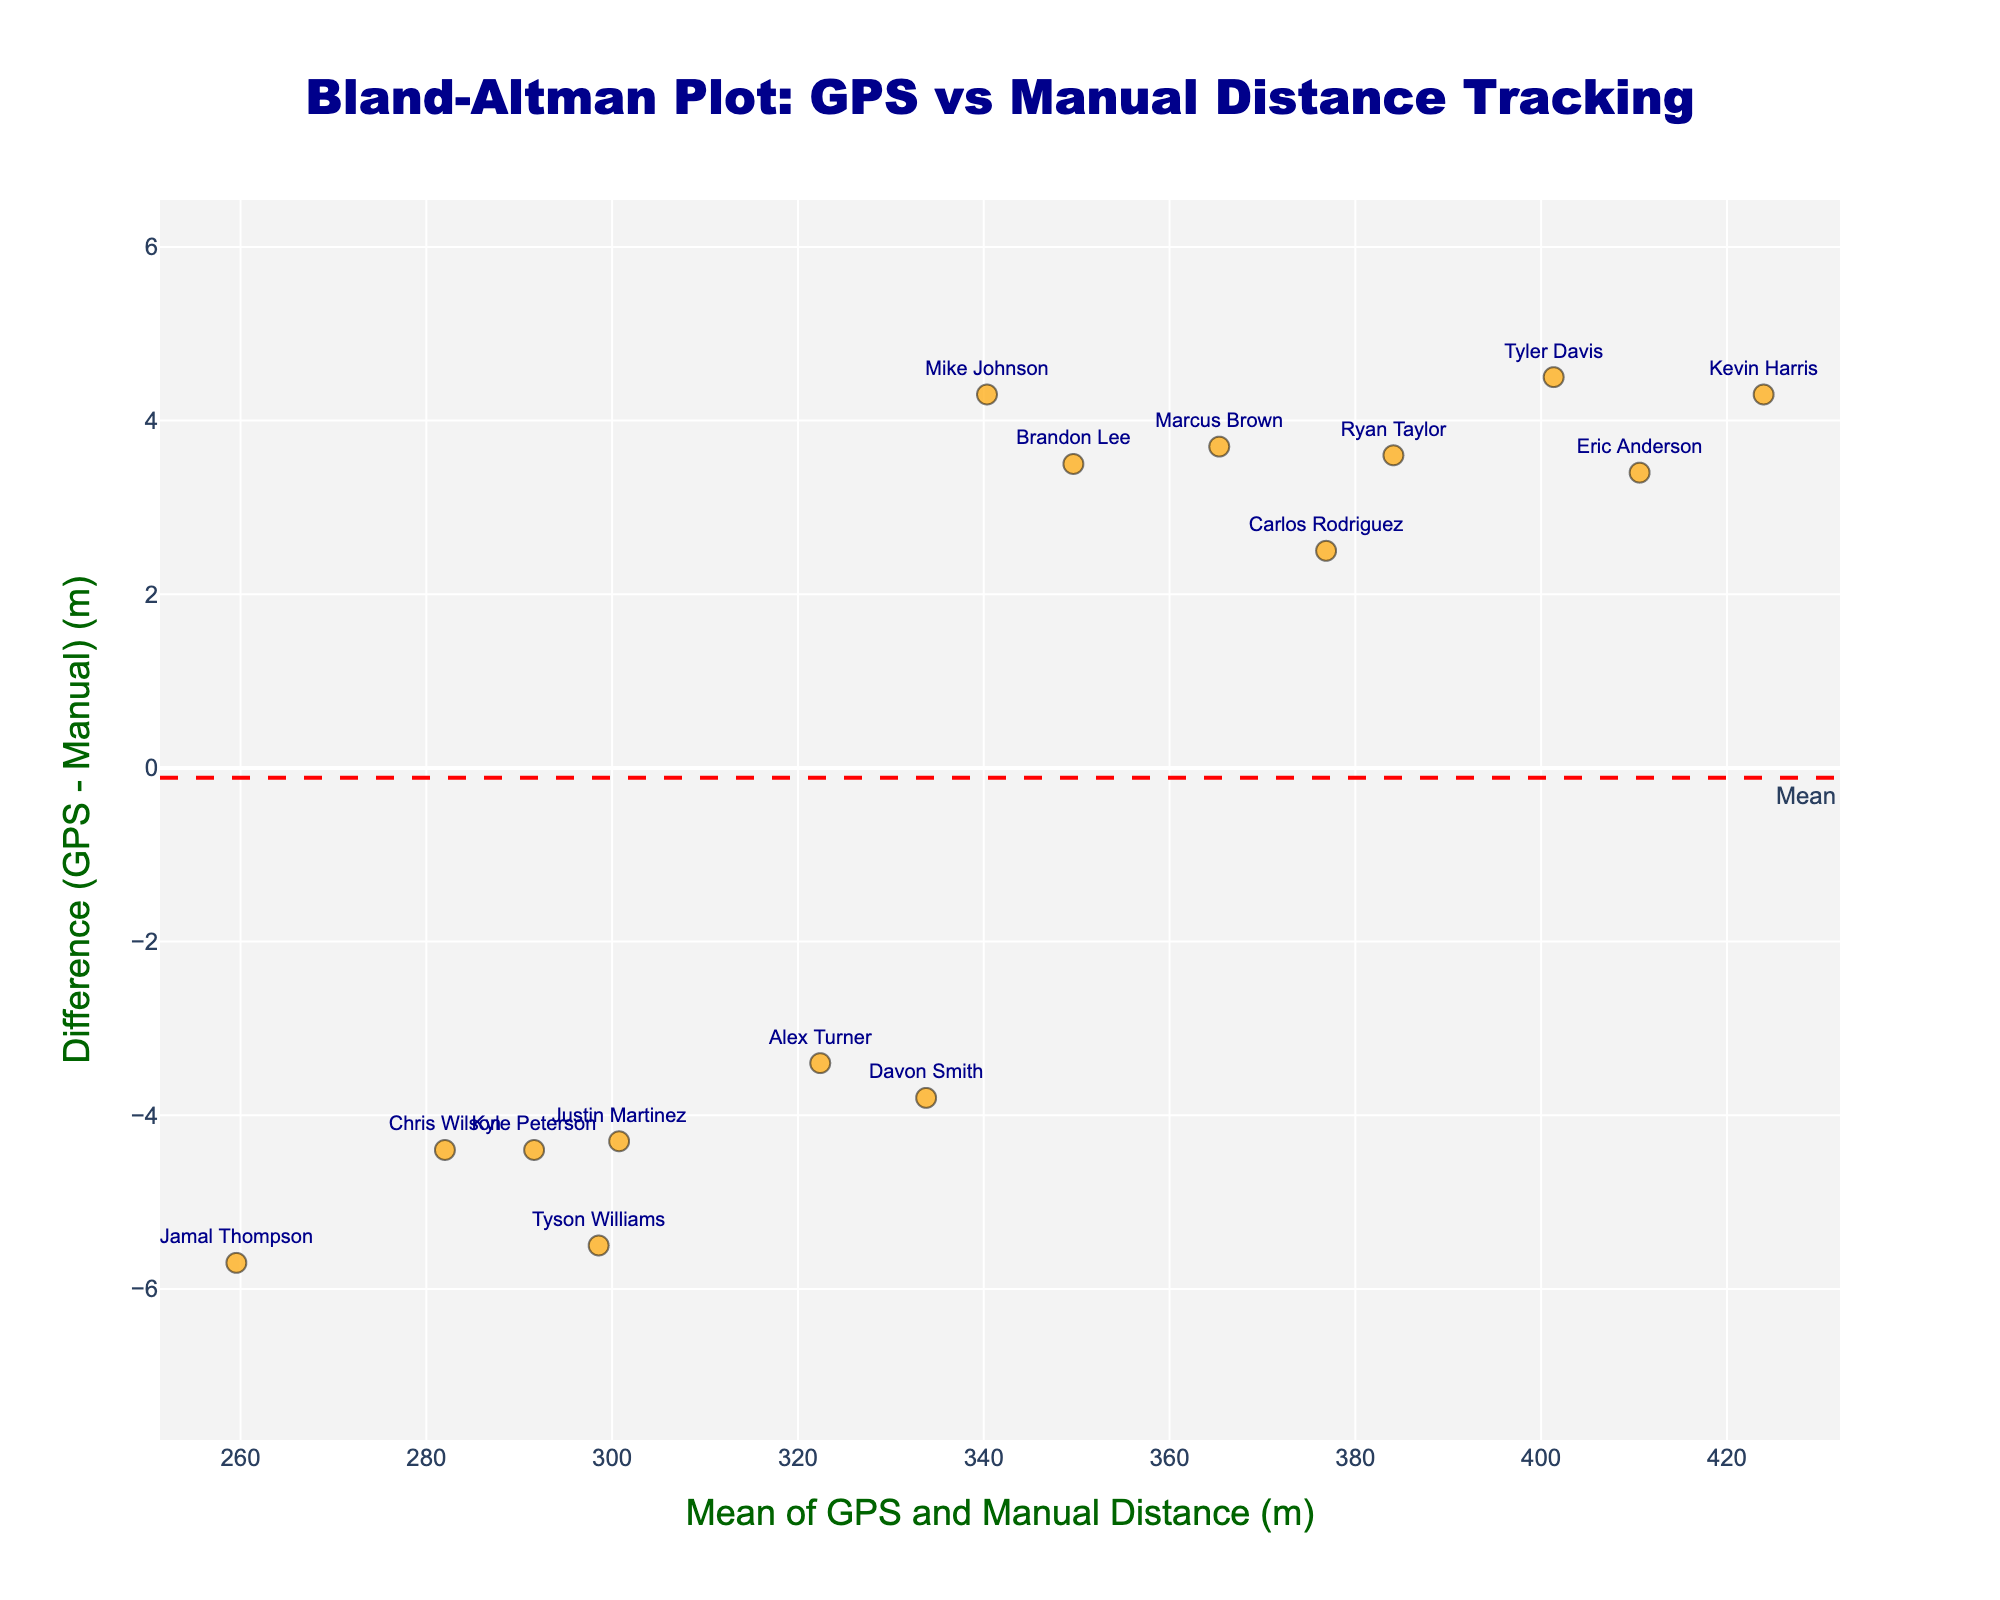what is the title of the plot? The title is usually located at the top of a plot. In this case, it is centered and described in dark blue font.
Answer: Bland-Altman Plot: GPS vs Manual Distance Tracking How many players' data points are shown in the plot? Each player in the data has a unique name, and each data point represents a player. Counting the players gives the total number of data points.
Answer: 15 What does the red dashed line in the plot represent? The red dashed line is located at a specific y-value and is labeled "Mean." It represents the mean difference between GPS and Manual distances.
Answer: Mean difference What do the green dotted lines in the plot signify? The green dotted lines are located above and below the red dashed line and are labeled "+1.96 SD" and "-1.96 SD." These lines represent the upper and lower limits of agreement.
Answer: Limits of agreement Which player has the highest mean distance, and what is that mean distance? By looking at the x-axis (mean of GPS and Manual distances), we find the rightmost data point and read the associated mean distance.
Answer: Kevin Harris, 423.95 meters Which player has the largest difference between GPS and manual measurements, and what is that difference? By looking at the y-axis (difference), we find the point furthest from y=0 and read the labeled difference. This can be seen as the highest absolute value from the mean line.
Answer: Kevin Harris, 4.3 meters Are there any players whose GPS and manual measurements are equal? If a player's point lies on y=0 (the line representing zero difference), then the GPS and Manual measurements for that player are equal.
Answer: No What's the range of mean distances covered? The mean distances are represented on the x-axis. Subtracting the smallest value from the largest gives the range.
Answer: 169.4 meters Is the mean difference within the limits of agreement? The mean difference (red dashed line) should be compared visually to the positions of the green dotted lines, which represent the upper and lower limits of agreement.
Answer: Yes What is the mean difference between GPS and manual distance measurements? The value of the mean difference is indicated by the red dashed line labeled "Mean."
Answer: Approximately 0.64 meters 